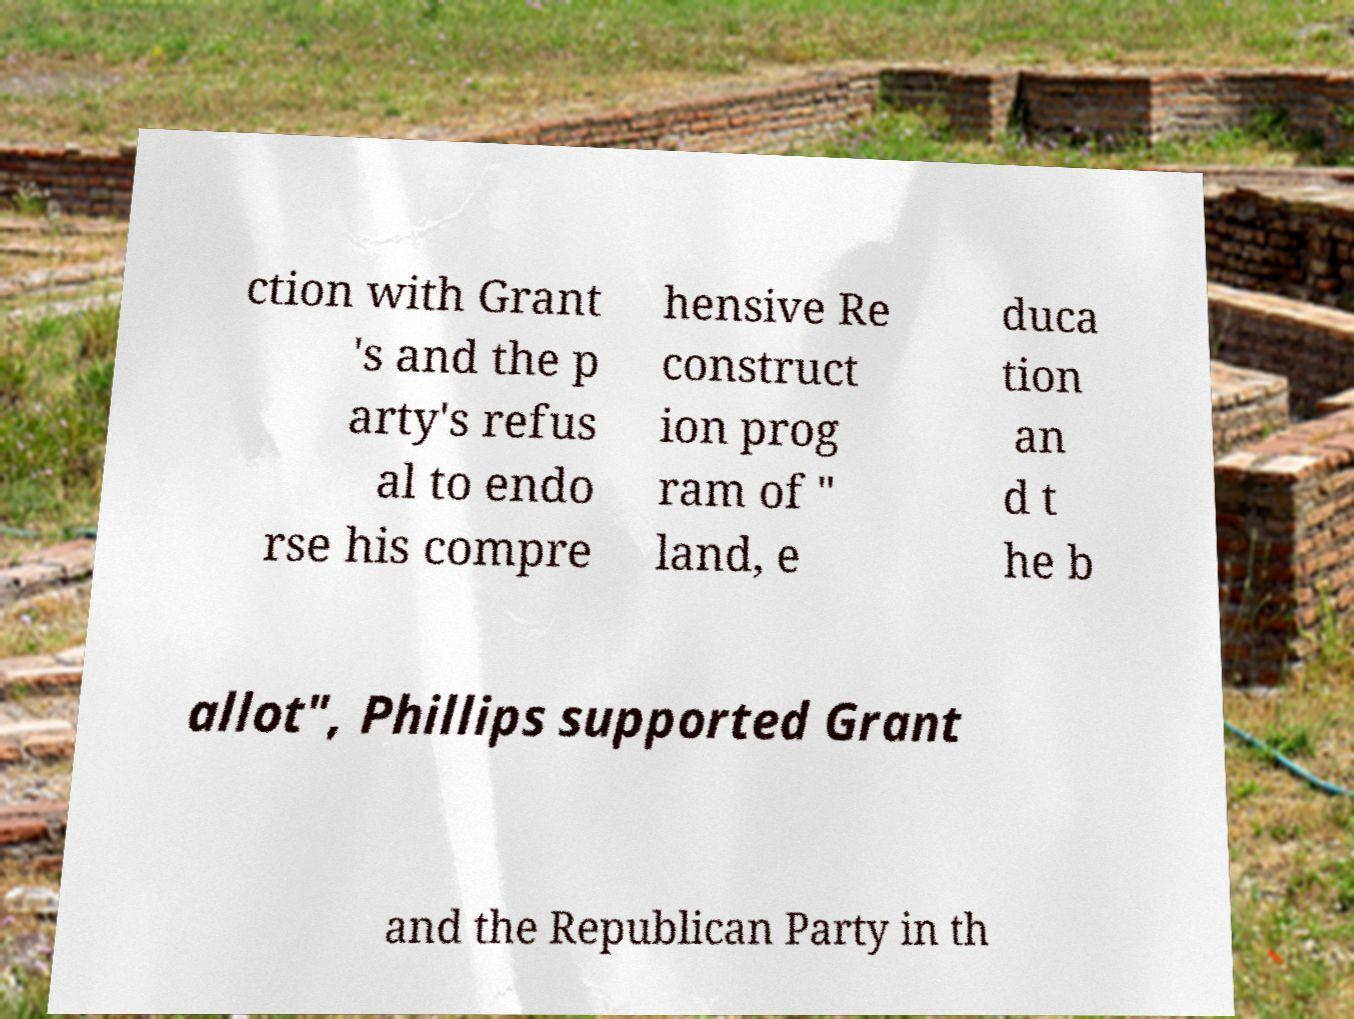Could you assist in decoding the text presented in this image and type it out clearly? ction with Grant 's and the p arty's refus al to endo rse his compre hensive Re construct ion prog ram of " land, e duca tion an d t he b allot", Phillips supported Grant and the Republican Party in th 